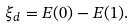Convert formula to latex. <formula><loc_0><loc_0><loc_500><loc_500>\xi _ { d } = E ( 0 ) - E ( 1 ) .</formula> 